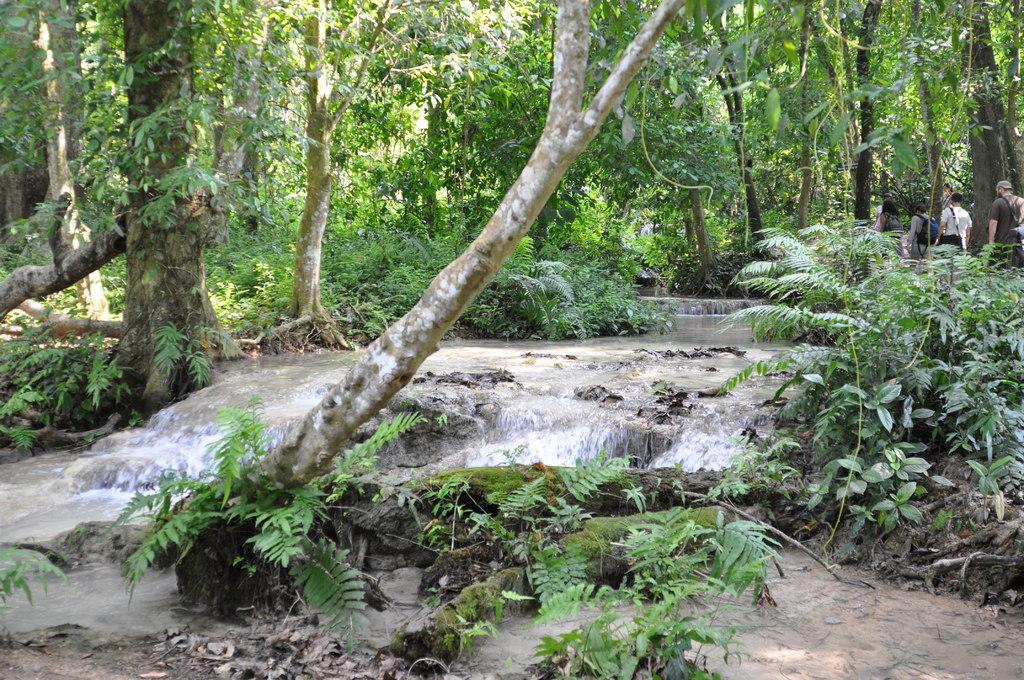What is happening in the image? There is water flow in the image. What type of vegetation can be seen in the image? There are green plants and trees in the image. Are there any people present in the image? Yes, there are people walking on the right side of the image. Where is the kitten playing in the hole in the image? There is no kitten or hole present in the image. How are the people controlling the water flow in the image? The image does not show any indication of people controlling the water flow; it is a natural occurrence. 